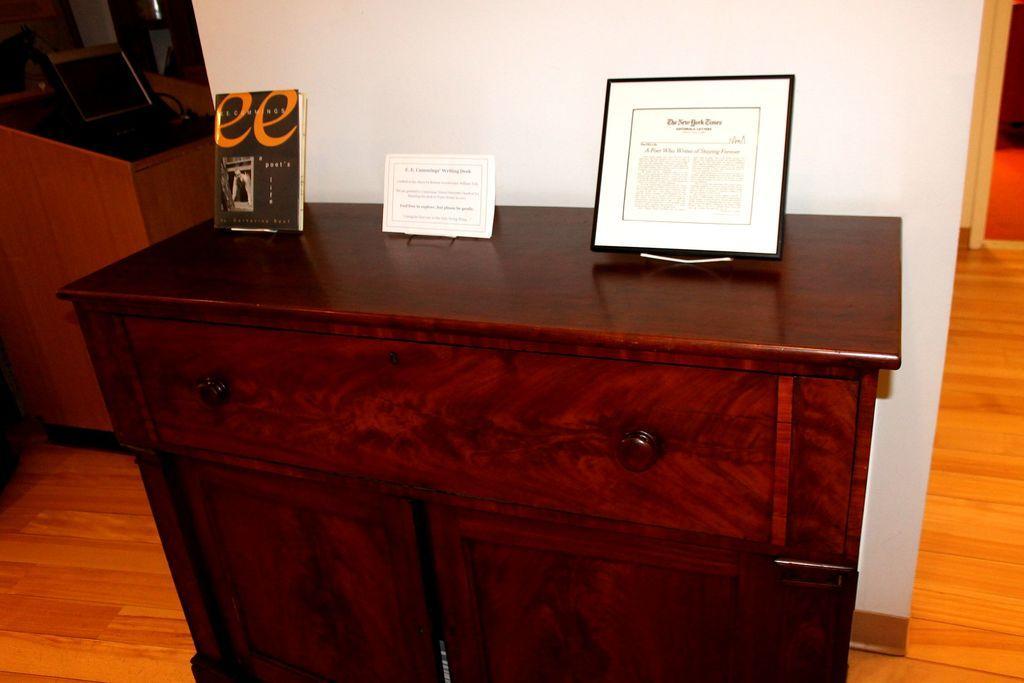Please provide a concise description of this image. There is a table in the image. On table there is a book, a paper, a frame. In the background there is a white color wall on left side there is a podium on top of the podium there is a laptop. 